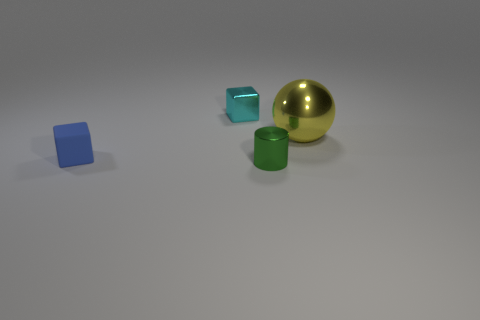There is a tiny metal object that is to the right of the small cyan metal block; is its color the same as the metal block?
Your answer should be very brief. No. What size is the metallic sphere?
Your answer should be very brief. Large. There is a block that is in front of the object that is behind the yellow metallic ball; what is its size?
Offer a very short reply. Small. What number of metallic cylinders have the same color as the big sphere?
Offer a very short reply. 0. How many blue blocks are there?
Make the answer very short. 1. How many small green objects are made of the same material as the tiny cyan object?
Provide a short and direct response. 1. What is the size of the other thing that is the same shape as the tiny cyan metal object?
Provide a short and direct response. Small. What is the small green object made of?
Provide a succinct answer. Metal. What is the material of the small object that is to the right of the tiny block behind the shiny object that is on the right side of the green metallic object?
Offer a terse response. Metal. Is there any other thing that has the same shape as the green shiny object?
Ensure brevity in your answer.  No. 